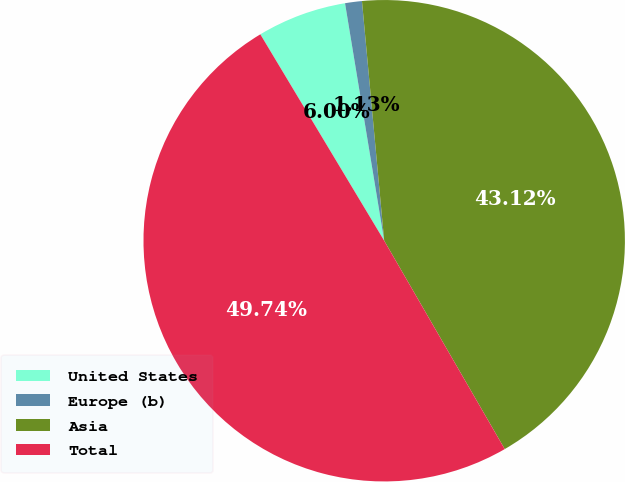Convert chart. <chart><loc_0><loc_0><loc_500><loc_500><pie_chart><fcel>United States<fcel>Europe (b)<fcel>Asia<fcel>Total<nl><fcel>6.0%<fcel>1.13%<fcel>43.12%<fcel>49.74%<nl></chart> 